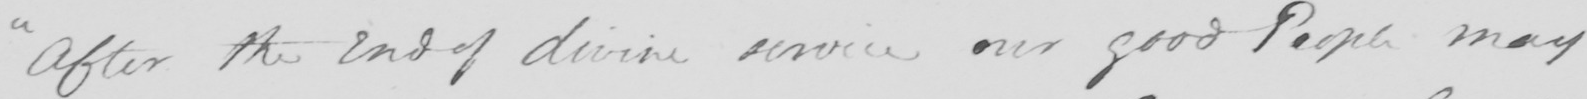Can you read and transcribe this handwriting? " After the end of divine service our good People may 